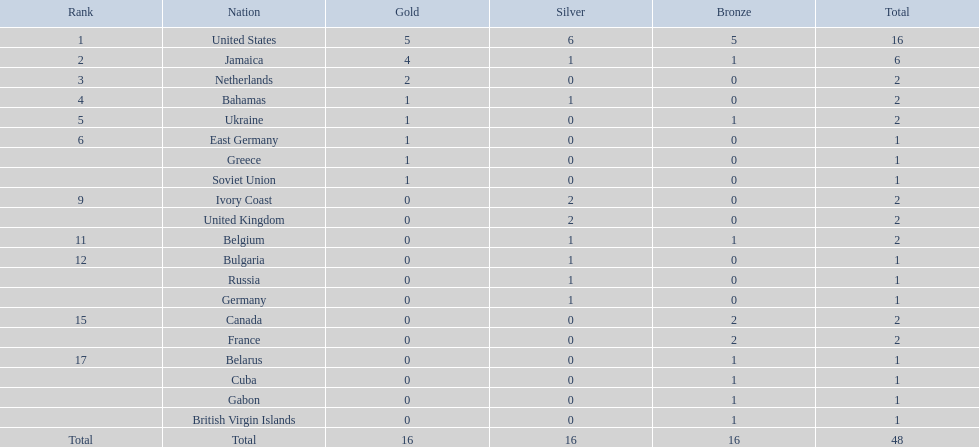Which countries won no less than one gold medal in the 60 meters race? United States, Jamaica, Netherlands, Bahamas, Ukraine, East Germany, Greece, Soviet Union. Out of these countries, which one captured the greatest amount of gold medals? United States. 